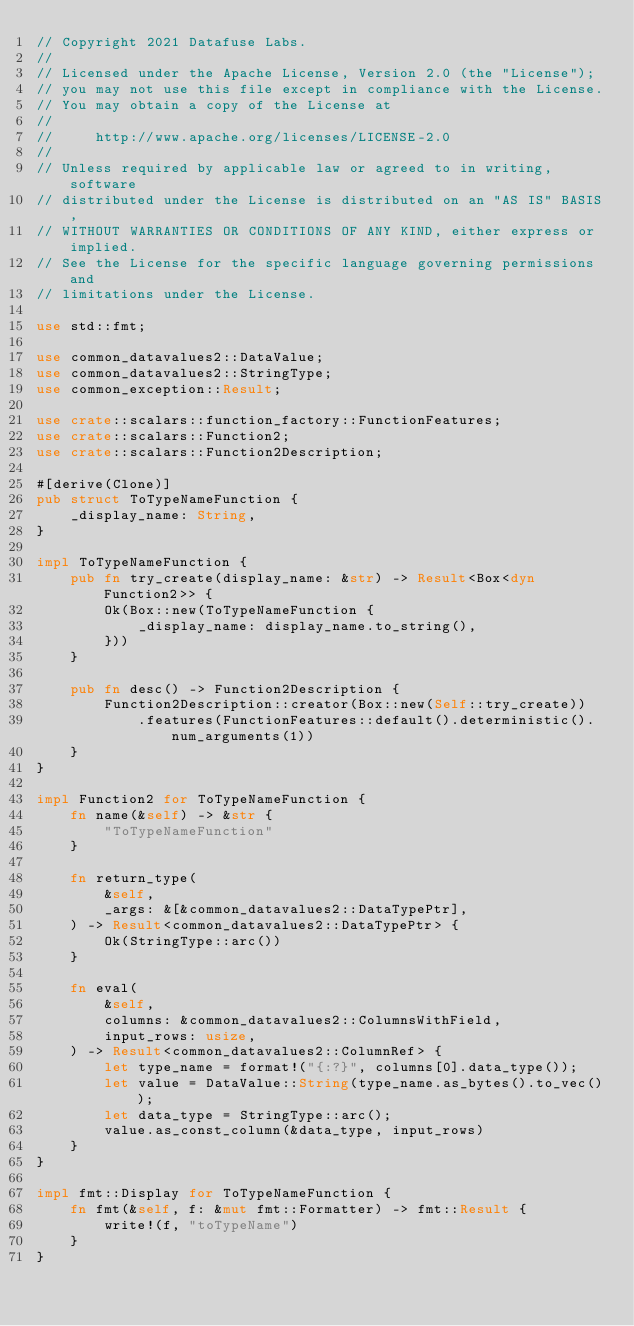Convert code to text. <code><loc_0><loc_0><loc_500><loc_500><_Rust_>// Copyright 2021 Datafuse Labs.
//
// Licensed under the Apache License, Version 2.0 (the "License");
// you may not use this file except in compliance with the License.
// You may obtain a copy of the License at
//
//     http://www.apache.org/licenses/LICENSE-2.0
//
// Unless required by applicable law or agreed to in writing, software
// distributed under the License is distributed on an "AS IS" BASIS,
// WITHOUT WARRANTIES OR CONDITIONS OF ANY KIND, either express or implied.
// See the License for the specific language governing permissions and
// limitations under the License.

use std::fmt;

use common_datavalues2::DataValue;
use common_datavalues2::StringType;
use common_exception::Result;

use crate::scalars::function_factory::FunctionFeatures;
use crate::scalars::Function2;
use crate::scalars::Function2Description;

#[derive(Clone)]
pub struct ToTypeNameFunction {
    _display_name: String,
}

impl ToTypeNameFunction {
    pub fn try_create(display_name: &str) -> Result<Box<dyn Function2>> {
        Ok(Box::new(ToTypeNameFunction {
            _display_name: display_name.to_string(),
        }))
    }

    pub fn desc() -> Function2Description {
        Function2Description::creator(Box::new(Self::try_create))
            .features(FunctionFeatures::default().deterministic().num_arguments(1))
    }
}

impl Function2 for ToTypeNameFunction {
    fn name(&self) -> &str {
        "ToTypeNameFunction"
    }

    fn return_type(
        &self,
        _args: &[&common_datavalues2::DataTypePtr],
    ) -> Result<common_datavalues2::DataTypePtr> {
        Ok(StringType::arc())
    }

    fn eval(
        &self,
        columns: &common_datavalues2::ColumnsWithField,
        input_rows: usize,
    ) -> Result<common_datavalues2::ColumnRef> {
        let type_name = format!("{:?}", columns[0].data_type());
        let value = DataValue::String(type_name.as_bytes().to_vec());
        let data_type = StringType::arc();
        value.as_const_column(&data_type, input_rows)
    }
}

impl fmt::Display for ToTypeNameFunction {
    fn fmt(&self, f: &mut fmt::Formatter) -> fmt::Result {
        write!(f, "toTypeName")
    }
}
</code> 